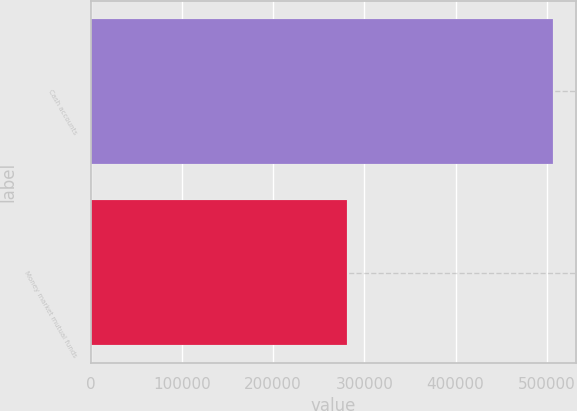Convert chart. <chart><loc_0><loc_0><loc_500><loc_500><bar_chart><fcel>Cash accounts<fcel>Money market mutual funds<nl><fcel>506731<fcel>281333<nl></chart> 